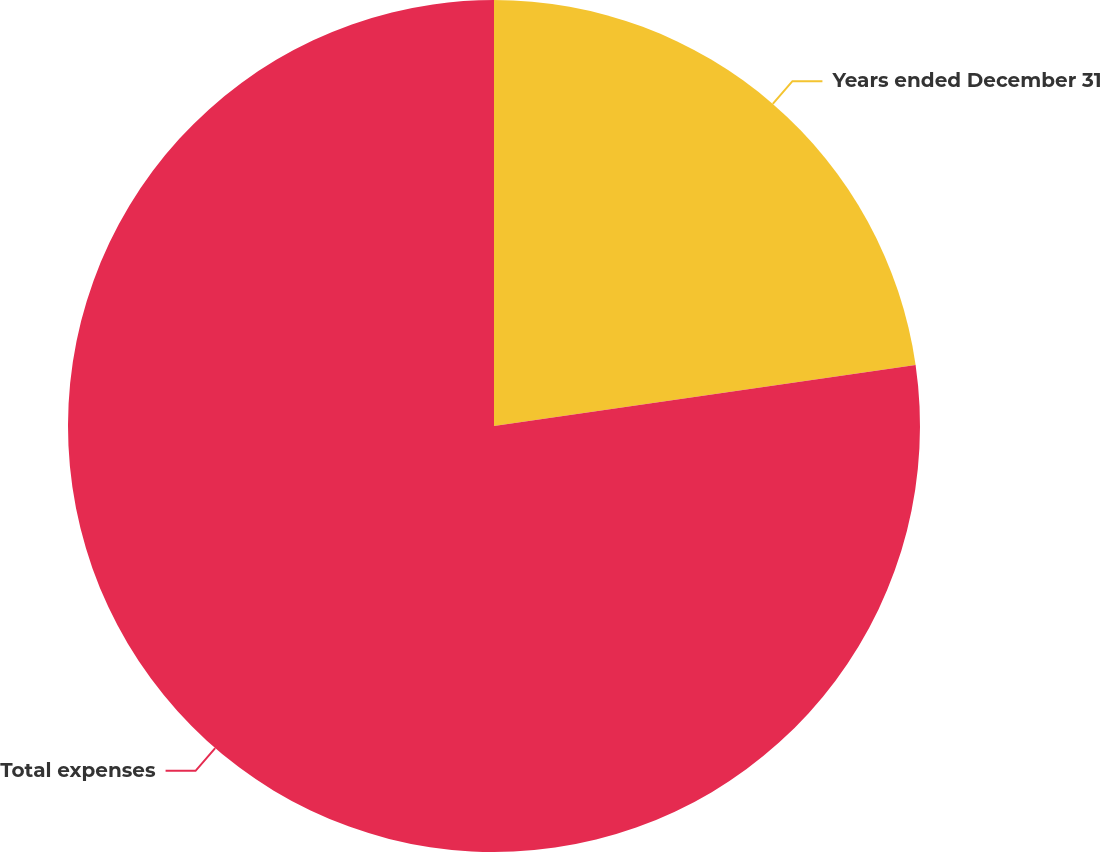Convert chart to OTSL. <chart><loc_0><loc_0><loc_500><loc_500><pie_chart><fcel>Years ended December 31<fcel>Total expenses<nl><fcel>22.71%<fcel>77.29%<nl></chart> 